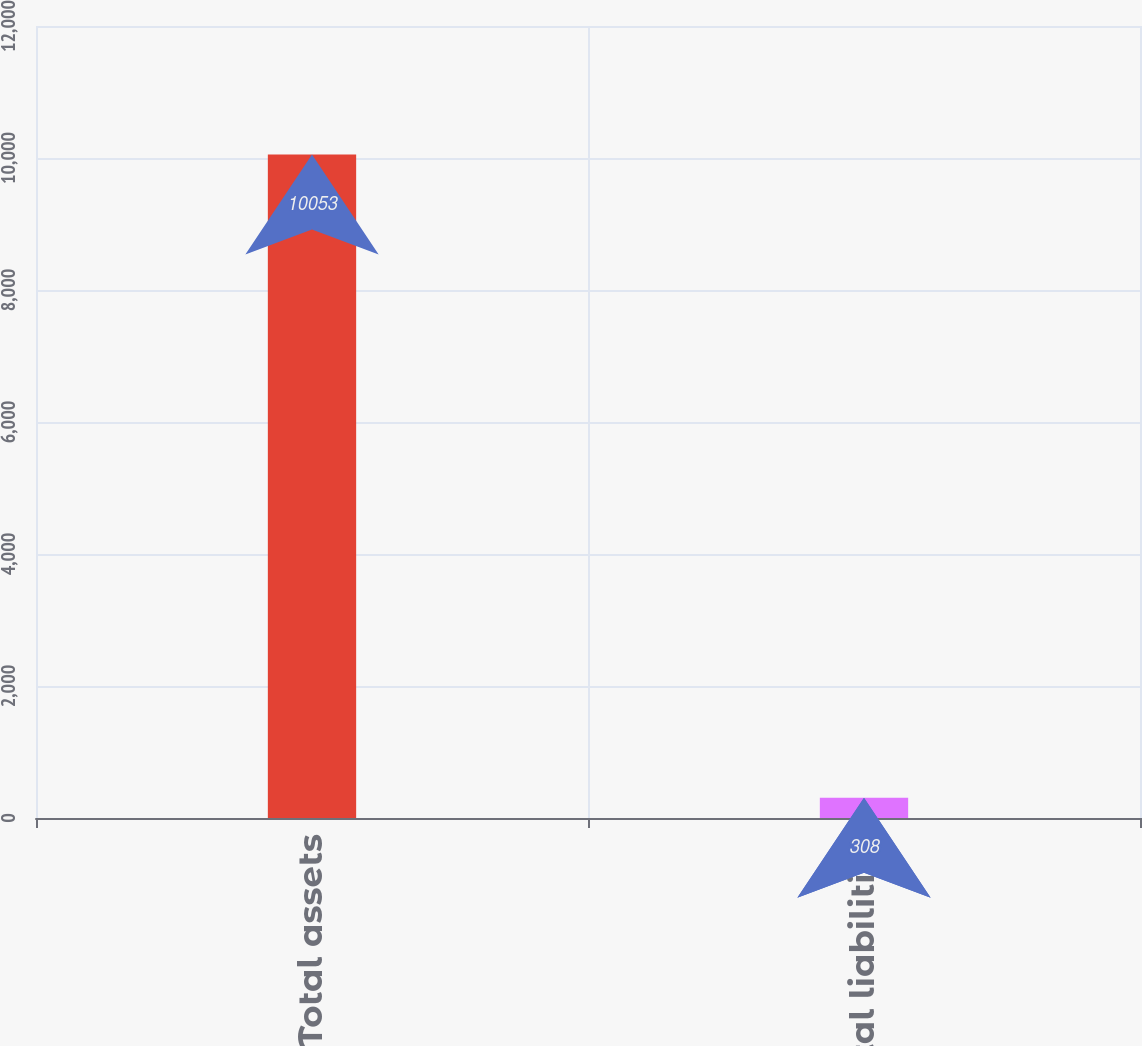Convert chart. <chart><loc_0><loc_0><loc_500><loc_500><bar_chart><fcel>Total assets<fcel>Total liabilities<nl><fcel>10053<fcel>308<nl></chart> 